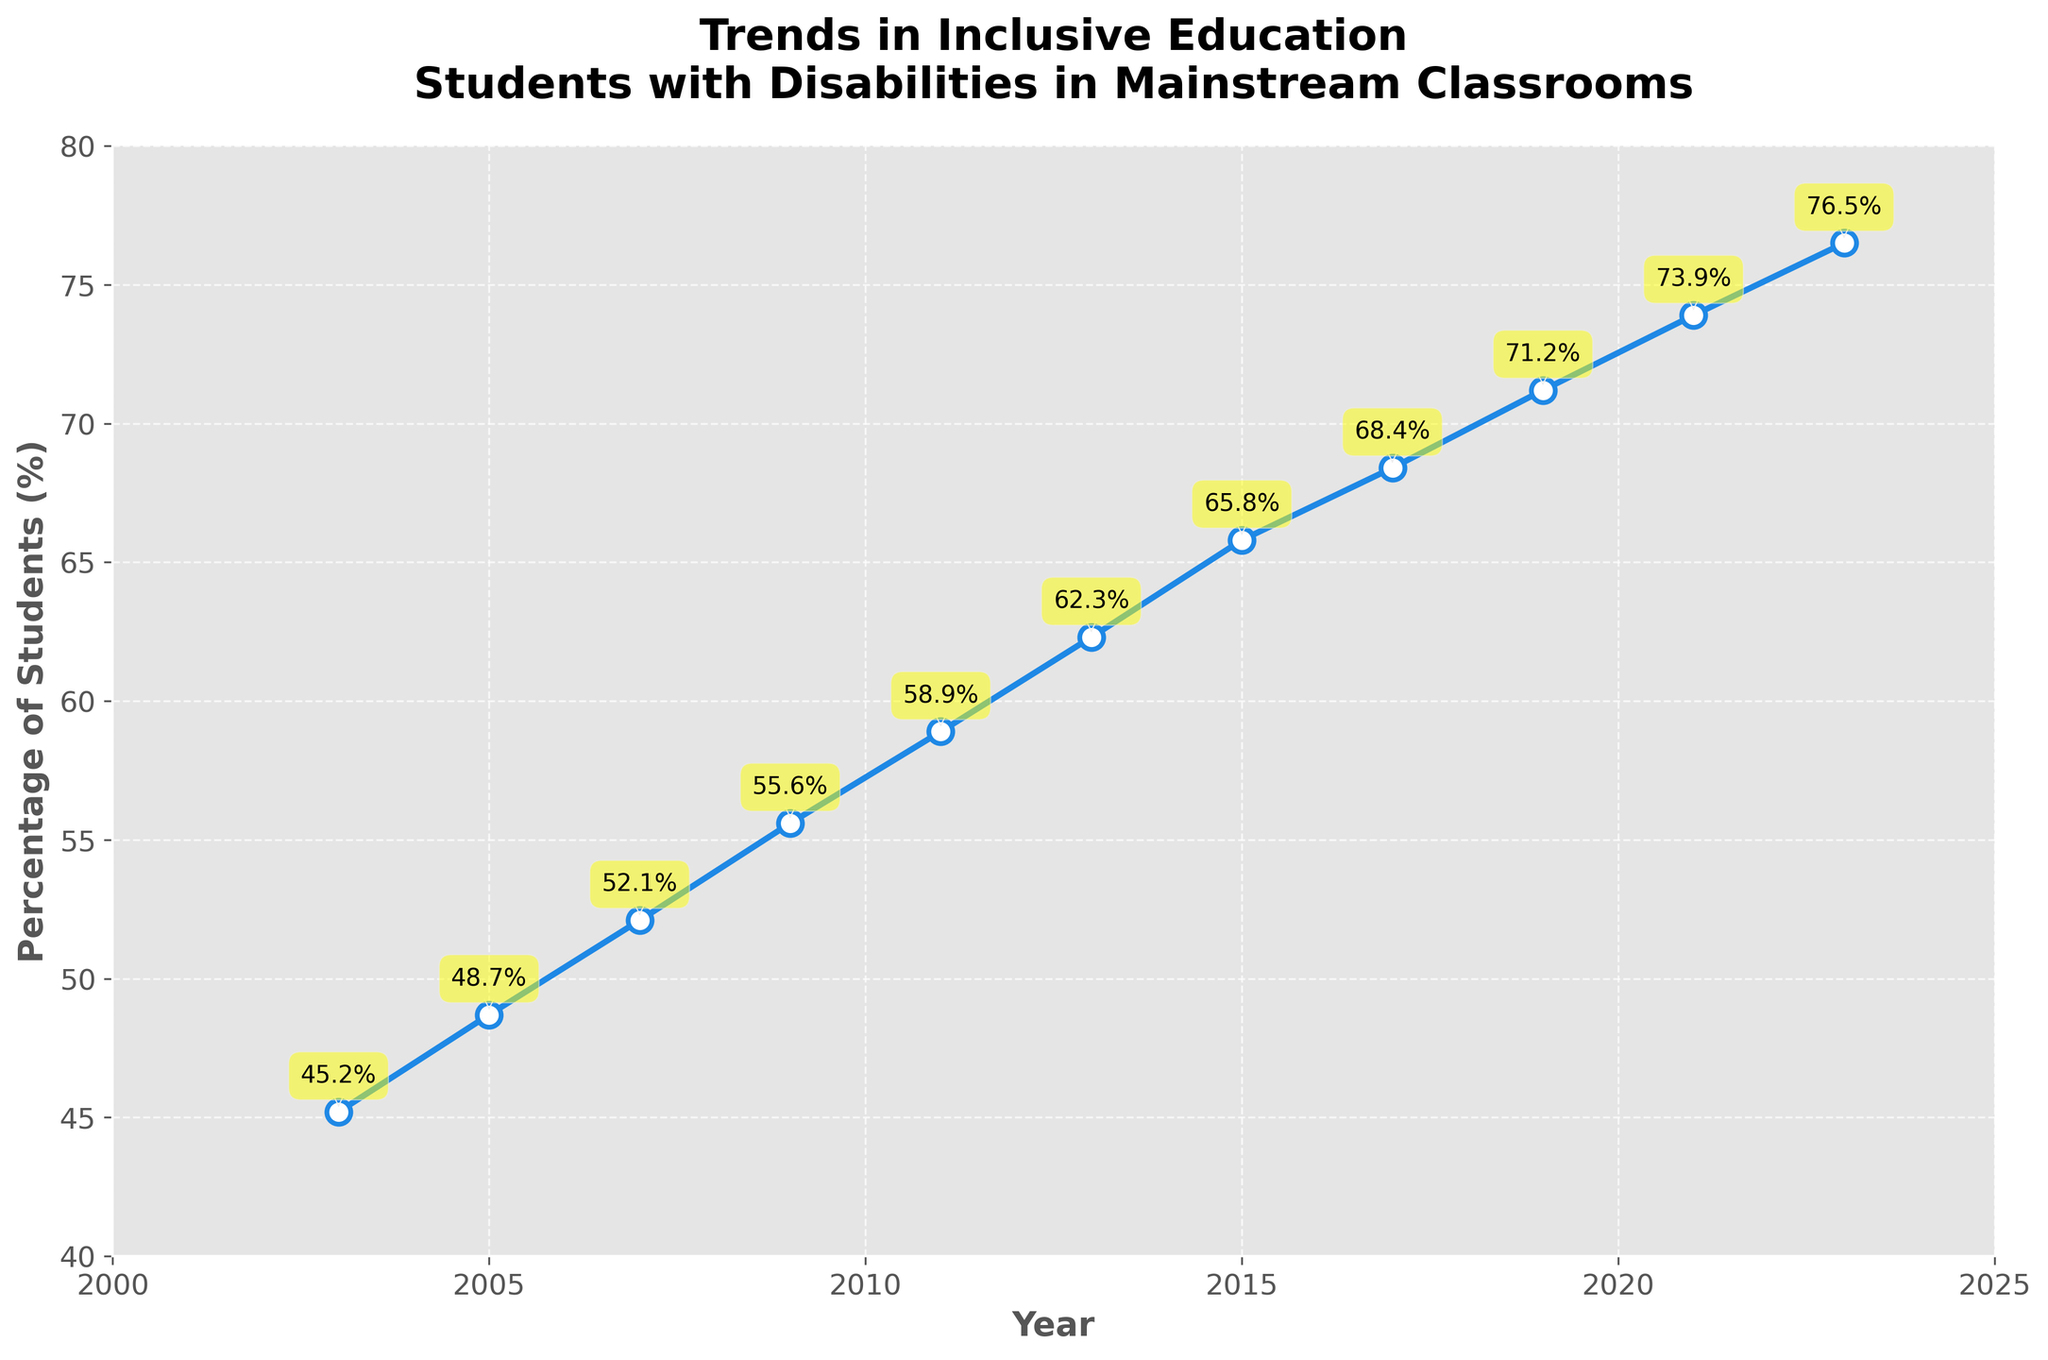What is the general trend shown in the figure? The line chart shows an upward trend, where the percentage of students with disabilities in mainstream classrooms has been increasing over the past 20 years. Every plotted point from 2003 to 2023 shows a higher percentage than the previous one.
Answer: Increasing What is the approximate percentage increase from 2003 to 2023? In 2003, the percentage was 45.2%, and in 2023, it is 76.5%. The percentage increase is calculated by subtracting the 2003 percentage from the 2023 percentage. 76.5 - 45.2 = 31.3
Answer: 31.3% During which year does the percentage first exceed 60%? By observing the data points on the chart, we can see that the first year the percentage exceeded 60% was in 2013 when the percentage was 62.3%.
Answer: 2013 Which year had the highest percentage of students with disabilities in mainstream classrooms? The line chart's endpoint displays the highest percentage, which is marked in 2023 at 76.5%.
Answer: 2023 What is the average percentage of students with disabilities in mainstream classrooms for the years 2017, 2019, and 2021? To calculate the average, sum up the percentages for 2017, 2019, and 2021, and then divide by 3. (68.4 + 71.2 + 73.9) / 3 = 213.5 / 3 ≈ 71.17
Answer: 71.17% How many years after 2003 did it take for the percentage to increase by approximately 20%? In 2003, the percentage was 45.2%. Adding 20% gives 45.2% + 20% = 65.2%. From the chart, 2015 has a percentage close to 65.2% (65.8%). To find the number of years, we subtract 2003 from 2015. 2015 - 2003 = 12
Answer: 12 years Which year is closest to the midpoint percentage of the full range shown in the chart? The range is from 45.2% in 2003 to 76.5% in 2023. The midpoint is (45.2 + 76.5) / 2 = 60.85%. The closest percentage to this midpoint is 2011 with 58.9%.
Answer: 2011 How many data points indicate that more than 70% of students with disabilities were in mainstream classrooms? According to the chart, the years 2019 (71.2%), 2021 (73.9%), and 2023 (76.5%) all report more than 70%. Counting these, we have 3 data points.
Answer: 3 